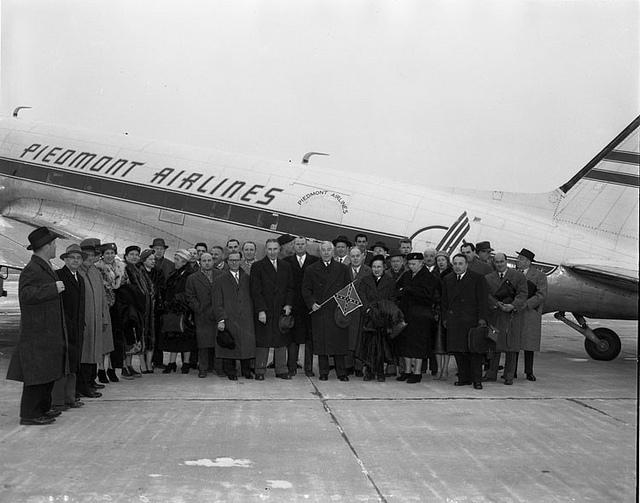Did they crash?
Keep it brief. No. Is this a recent photo?
Write a very short answer. No. Are they wearing coats?
Answer briefly. Yes. What airline is on the plane?
Answer briefly. Piedmont. 